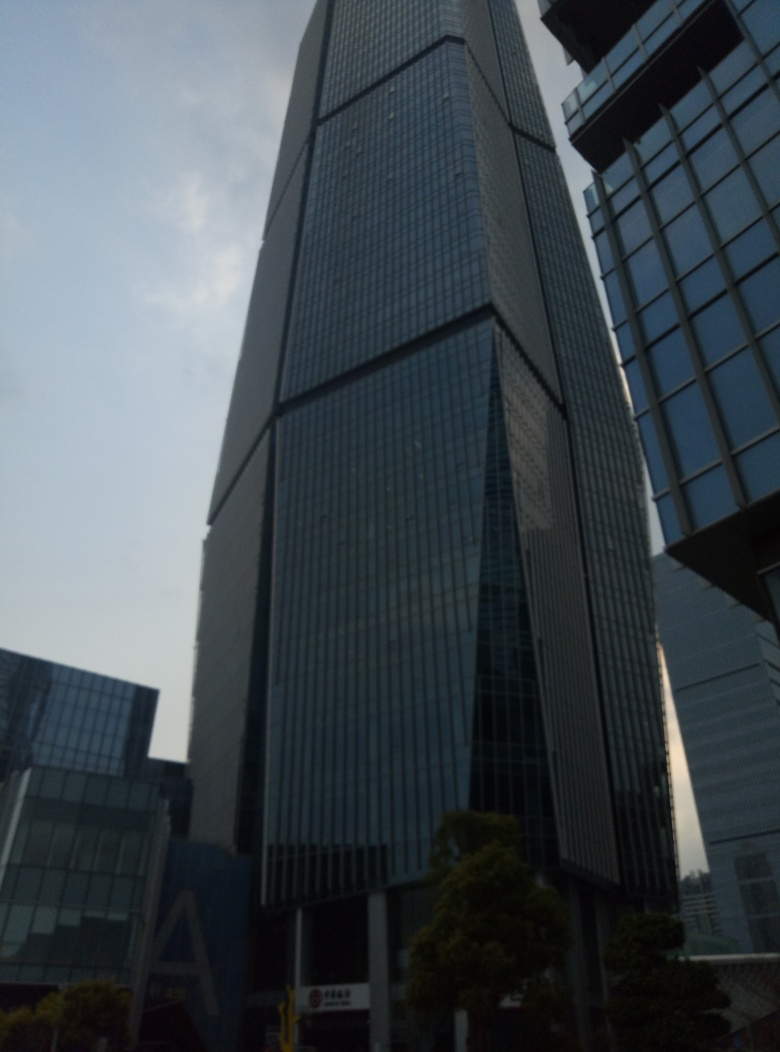What could be the purpose of such a tall building in a city's skyline? Tall buildings in a city's skyline, like the one pictured, commonly serve multiple purposes. Primarily, they are practical solutions to space limitations, offering a large amount of floor space within a relatively small footprint. They also typify economic prowess, housing major businesses, financial institutions, or luxury apartments. Additionally, skyscrapers like this can become iconic landmarks, contributing to the city's identity and aesthetic. They're also indicative of advanced engineering and architectural achievements. 